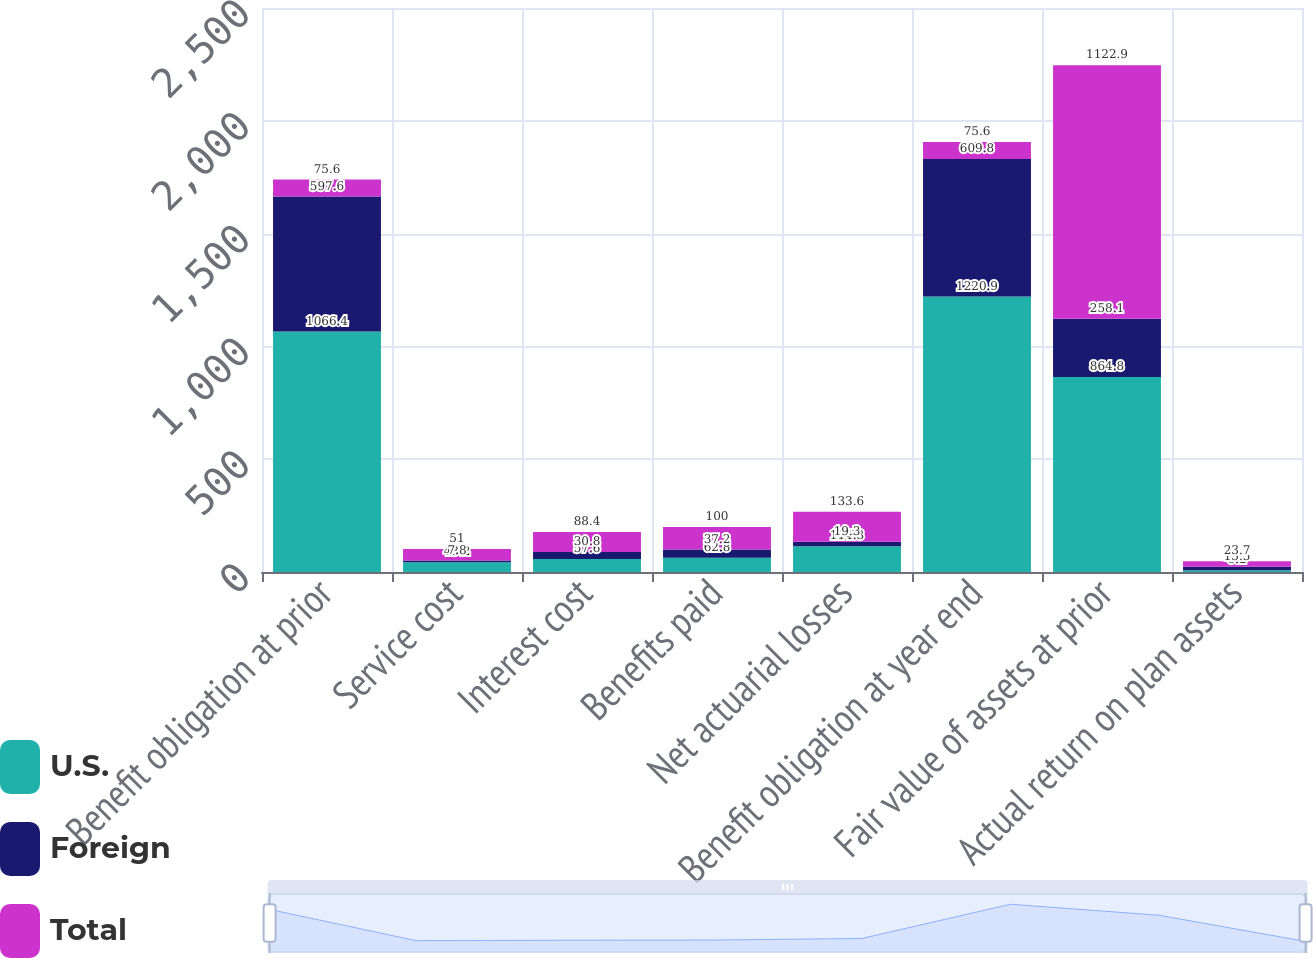Convert chart to OTSL. <chart><loc_0><loc_0><loc_500><loc_500><stacked_bar_chart><ecel><fcel>Benefit obligation at prior<fcel>Service cost<fcel>Interest cost<fcel>Benefits paid<fcel>Net actuarial losses<fcel>Benefit obligation at year end<fcel>Fair value of assets at prior<fcel>Actual return on plan assets<nl><fcel>U.S.<fcel>1066.4<fcel>43.2<fcel>57.6<fcel>62.8<fcel>114.3<fcel>1220.9<fcel>864.8<fcel>8.2<nl><fcel>Foreign<fcel>597.6<fcel>7.8<fcel>30.8<fcel>37.2<fcel>19.3<fcel>609.8<fcel>258.1<fcel>15.5<nl><fcel>Total<fcel>75.6<fcel>51<fcel>88.4<fcel>100<fcel>133.6<fcel>75.6<fcel>1122.9<fcel>23.7<nl></chart> 